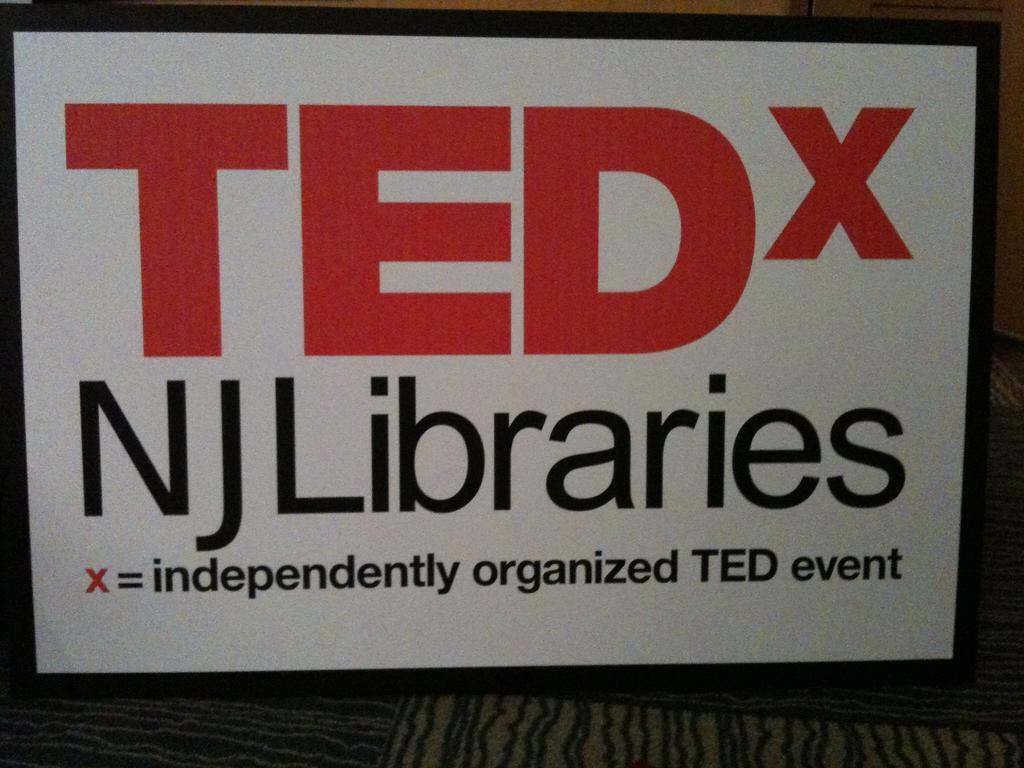<image>
Describe the image concisely. A Poster with Ted X on the top in big red letters 